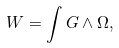Convert formula to latex. <formula><loc_0><loc_0><loc_500><loc_500>W = \int G \wedge \Omega ,</formula> 